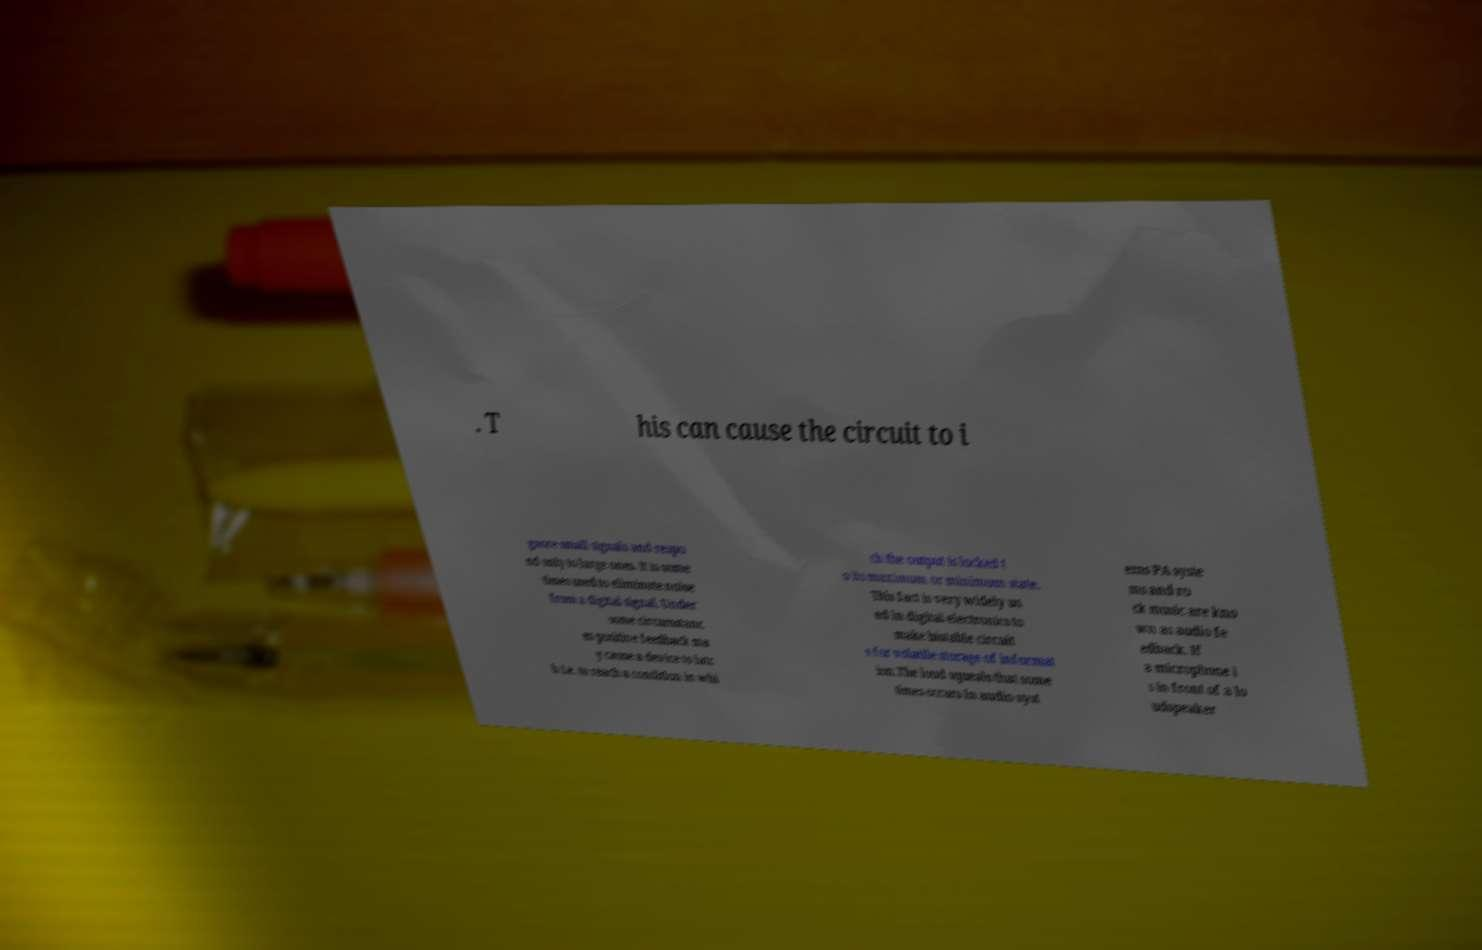Please read and relay the text visible in this image. What does it say? . T his can cause the circuit to i gnore small signals and respo nd only to large ones. It is some times used to eliminate noise from a digital signal. Under some circumstanc es positive feedback ma y cause a device to latc h i.e. to reach a condition in whi ch the output is locked t o its maximum or minimum state. This fact is very widely us ed in digital electronics to make bistable circuit s for volatile storage of informat ion.The loud squeals that some times occurs in audio syst ems PA syste ms and ro ck music are kno wn as audio fe edback. If a microphone i s in front of a lo udspeaker 